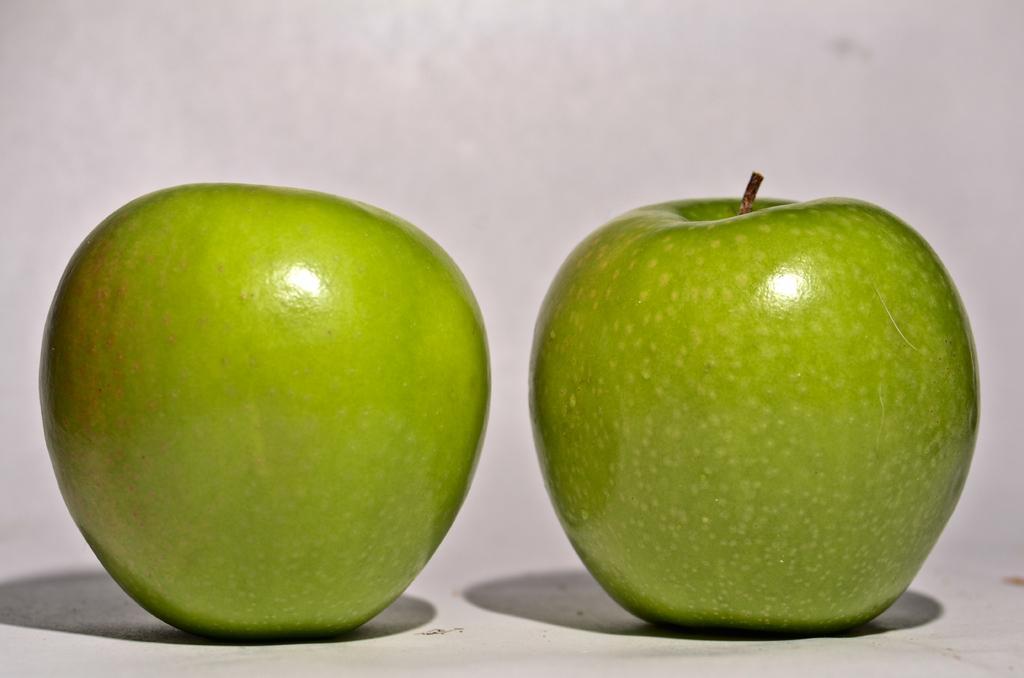How would you summarize this image in a sentence or two? In the image we can see two green apples kept on the white surface. 